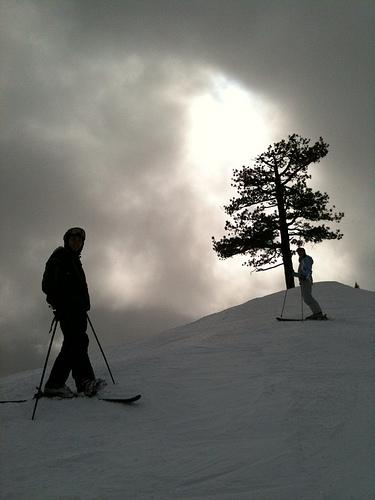Can you provide a detailed description of the image's scenery? The image features a snowy hill with skiers, a tree at the top, and a dark, cloudy sky with the sun peeking through the clouds. Identify all objects related to skiing in the image. Skis, ski poles, ski goggles, boots, snow gear, and helmet. What is the weather in this image, and what is the condition of the sky? It seems to be a cold, winter day with a dark, grey, and cloudy sky. How many skiers are present in the image, and what are they wearing? There are two skiers; one is wearing a black ski suit, and the other is wearing a blue jacket and white snow pants. Based on the image, what emotions or feelings can be associated with the scene? Excitement, adventure, and thrill of skiing, along with the serene and peaceful nature of a snow-covered hill. Analyze the interaction between the skiers and their environment. The skiers are actively engaging with the snowy hill by skiing on it, using their ski gear to navigate and maintain balance. Determine if any objects or elements in the image indicate movement or speed. The skiing action of the people and the lifted shoe off of a ski suggest movement and speed in the image. What is the primary activity happening in the image? People are skiing on a snow-covered hill. How many total objects are related to the sky in the image? There are four objects related to the sky: clouds, the sun, light showing through the clouds, and the sky itself. Count the number of trees in the image. There is only one tree in the image. Find anything unusual in the image. there is a smiling face on the skier's helmet Can you see the sun in the image? yes, it's peeking through the clouds Rate the image quality from 1 to 5 (1 being lowest and 5 being highest). 4 What is the person wearing on their head? snow goggles and a helmet Analyze how the skiers interact with their environment. both skiers are skiing down the hill, maneuvering with their ski poles while wearing ski gear What is the person in the black snowsuit doing? skiing on the snow-covered hill What color is the ski pole? not visible due to shadows Is the tree on the hill an evergreen tree? yes Describe the state of the sky in the image. dark, cloudy List the attributes of the person wearing a blue jacket and white snowpants. position - X:291 Y:247, size - Width:36 Height:36 Locate the clouds above a ski mountain in the image. X:126 Y:248 Width:69 Height:69 What are the main objects on the snowy hill? skiers, tree, snow How many trees are there in the image? one tree Identify and describe the main objects in the image. skier with skis and poles, tree on top of skiing mountain, sun peeking through clouds, snow-covered hill Determine the overall sentiment of the image. positive, as it shows people enjoying skiing in a beautiful snowy landscape Detect any text or numbers present in the image. no text or numbers found Describe the condition of the ground in the image. covered in white snow Are the people skiing happy or sad? happy 